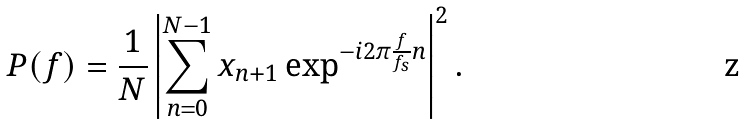<formula> <loc_0><loc_0><loc_500><loc_500>P ( f ) = \frac { 1 } { N } \left | \sum ^ { N - 1 } _ { n = 0 } x _ { n + 1 } \exp ^ { - i 2 \pi \frac { f } { f _ { s } } n } \right | ^ { 2 } .</formula> 